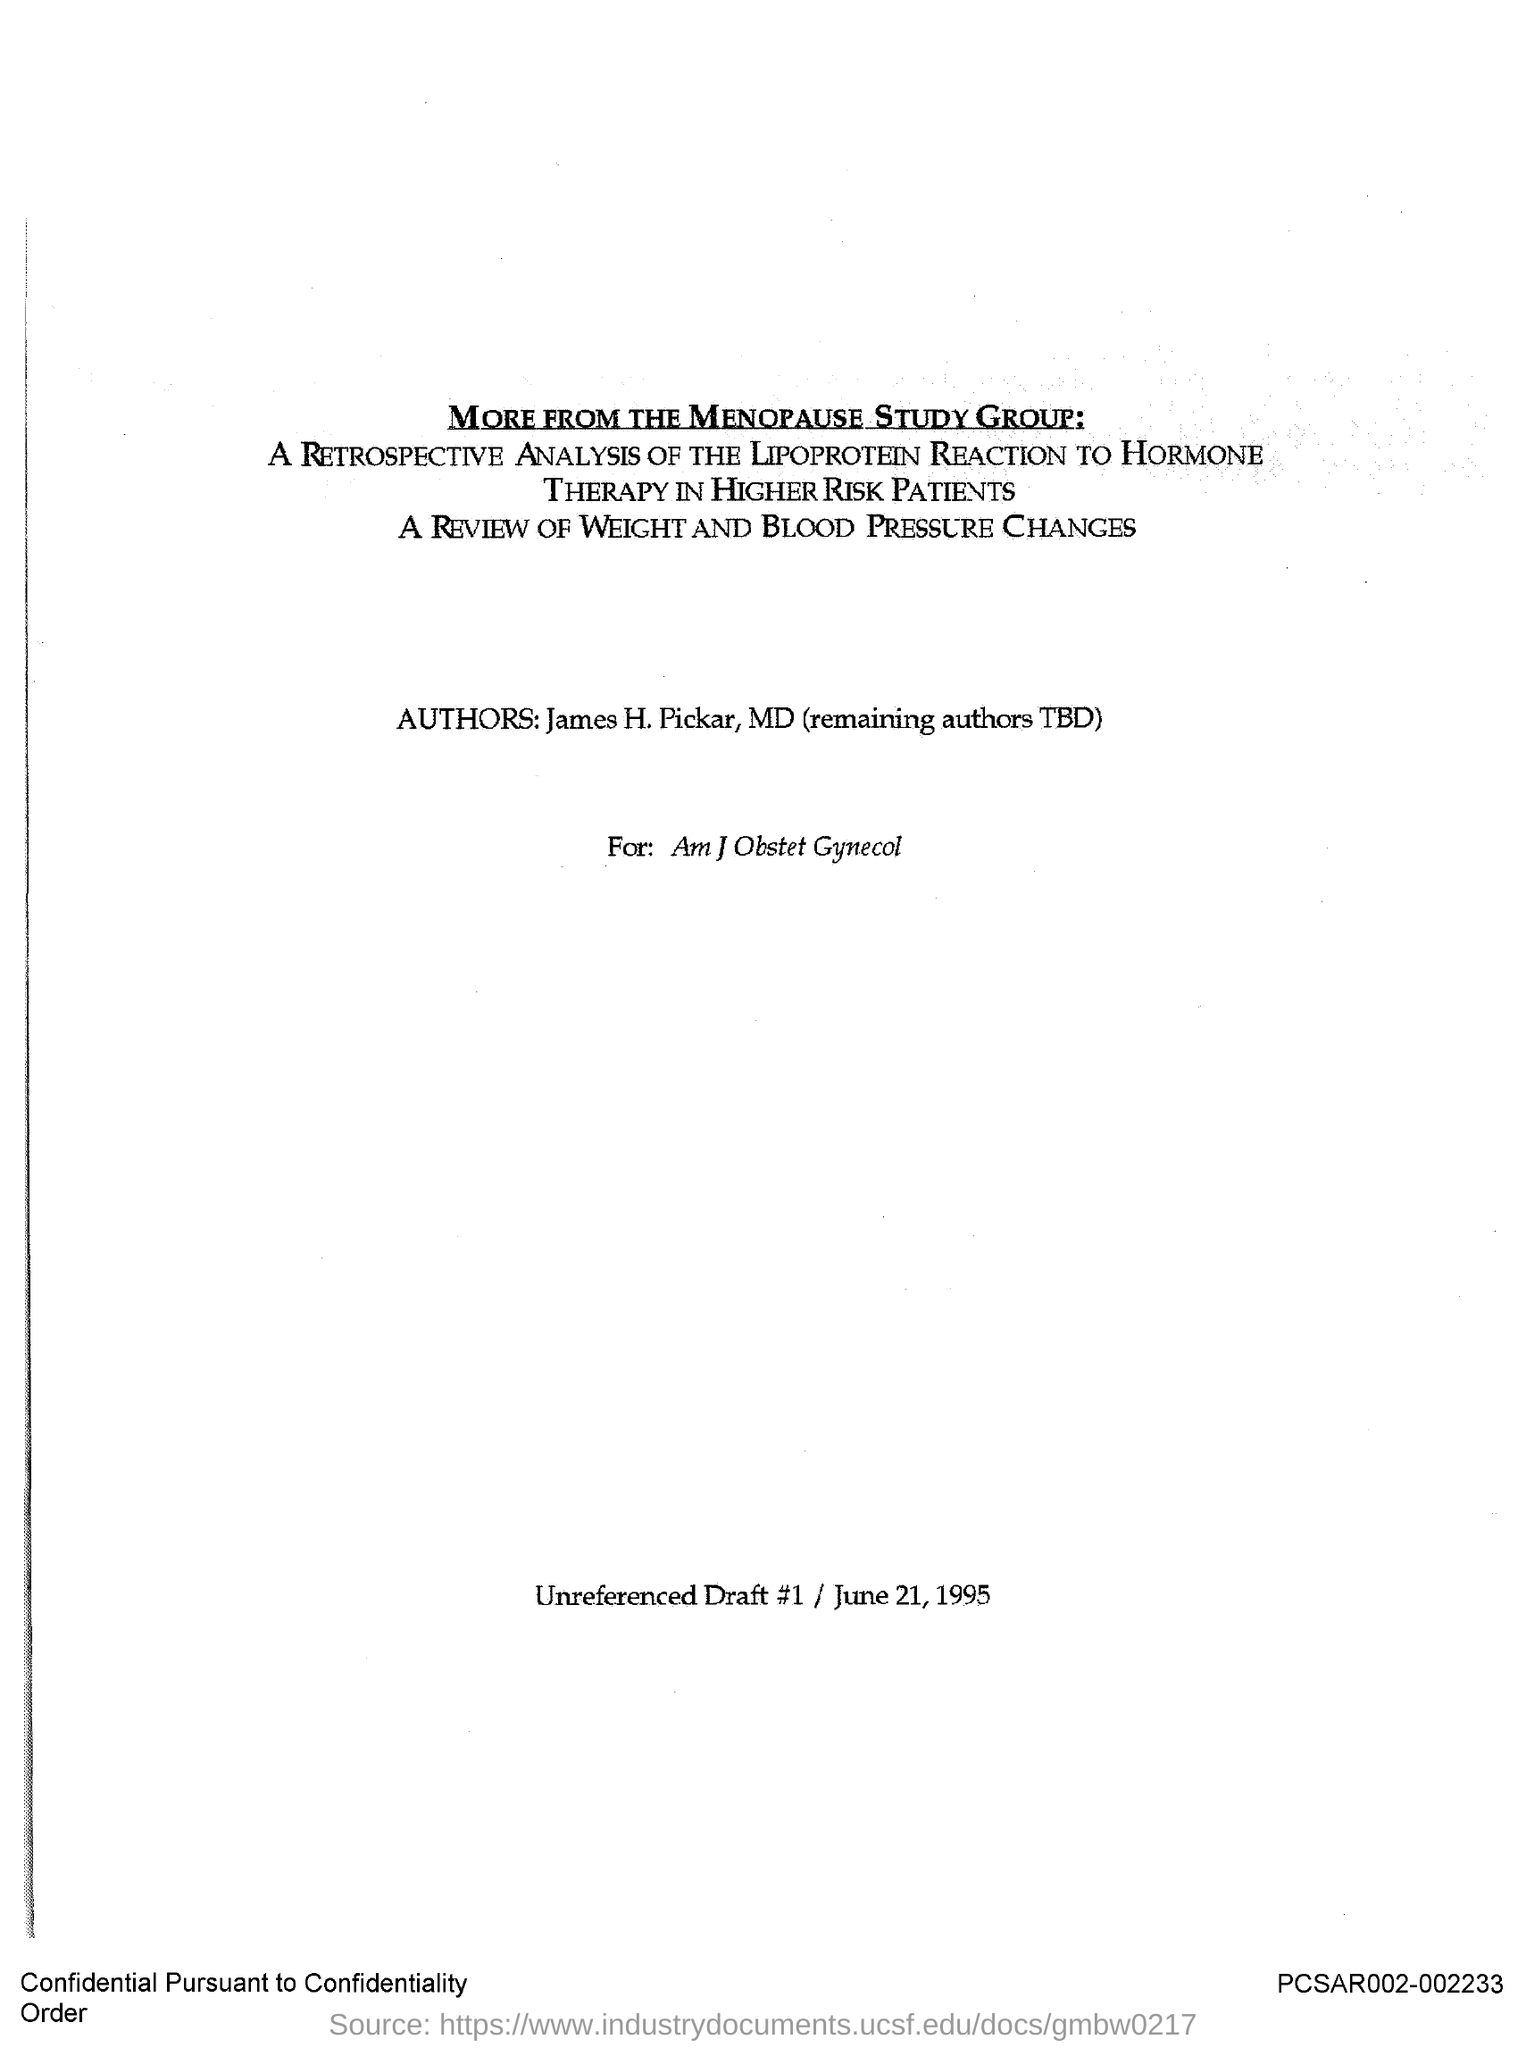Indicate a few pertinent items in this graphic. The document contains the date of June 21, 1995. The authors mentioned are James H. Pickar, MD. The study group named at the top is the Menopause Study Group. The category of patients that is studied in this report is higher risk patients. 